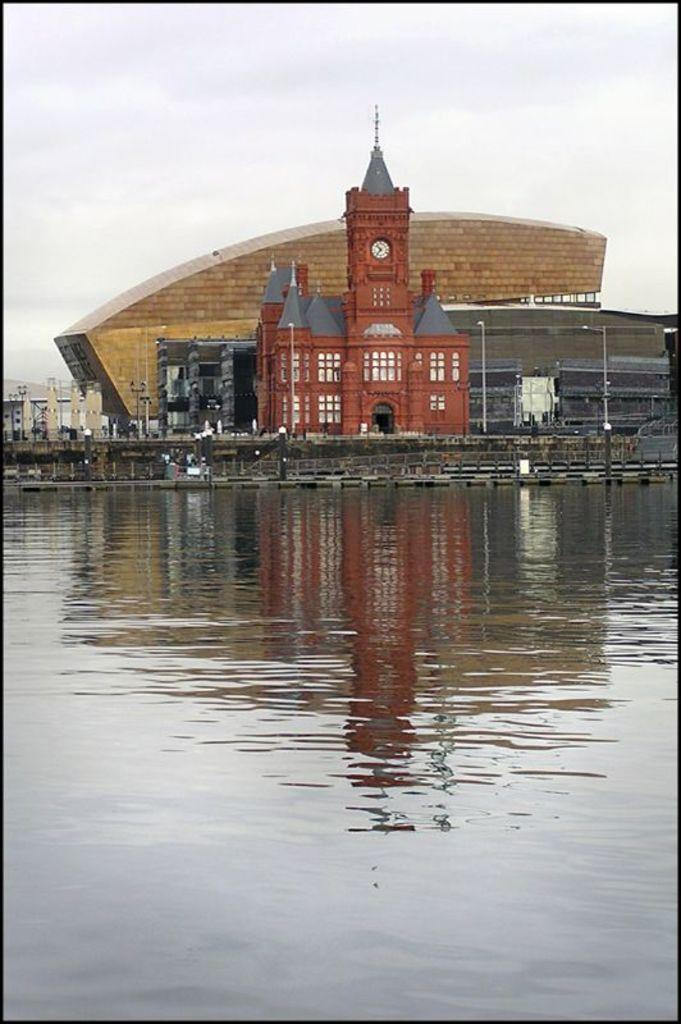What is the primary element visible in the image? There is water in the image. What type of structures can be seen in the image? There are buildings in the image. What time-telling device is present in the image? There is a clock in the image. What architectural feature is visible in the image? There are windows in the image. What is visible at the top of the image? The sky is visible at the top of the image. How many steps can be seen leading up to the cannon in the image? There is no cannon present in the image, so there are no steps leading up to it. 